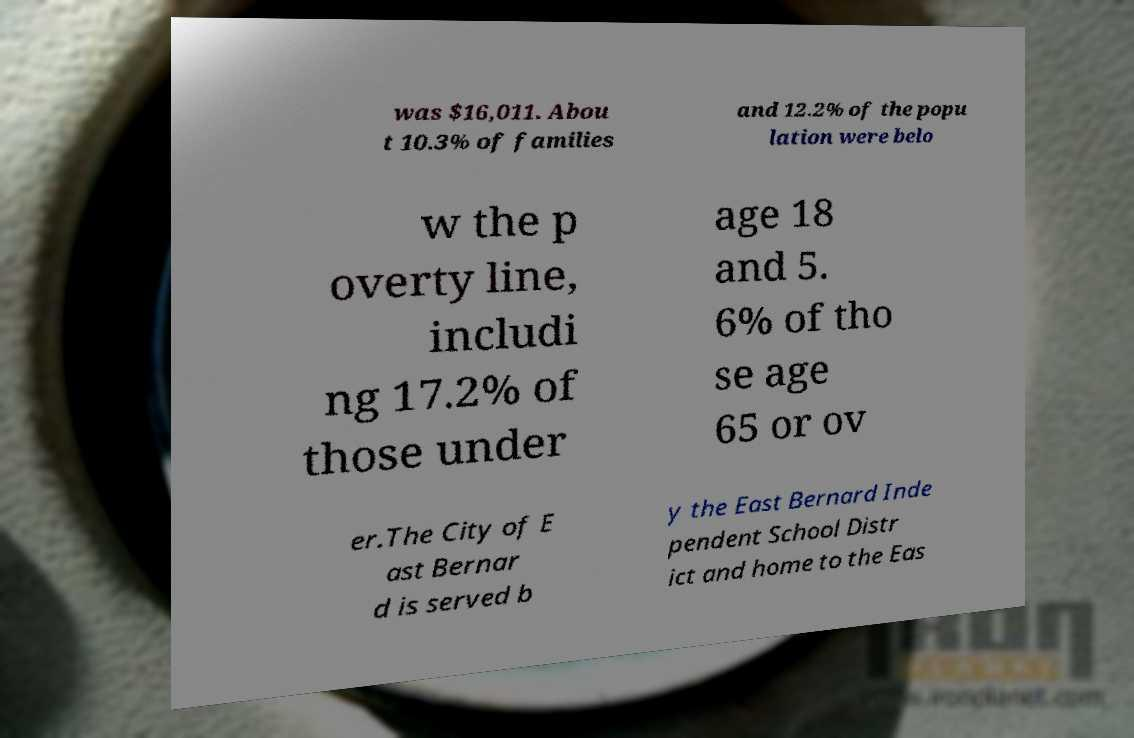What messages or text are displayed in this image? I need them in a readable, typed format. was $16,011. Abou t 10.3% of families and 12.2% of the popu lation were belo w the p overty line, includi ng 17.2% of those under age 18 and 5. 6% of tho se age 65 or ov er.The City of E ast Bernar d is served b y the East Bernard Inde pendent School Distr ict and home to the Eas 